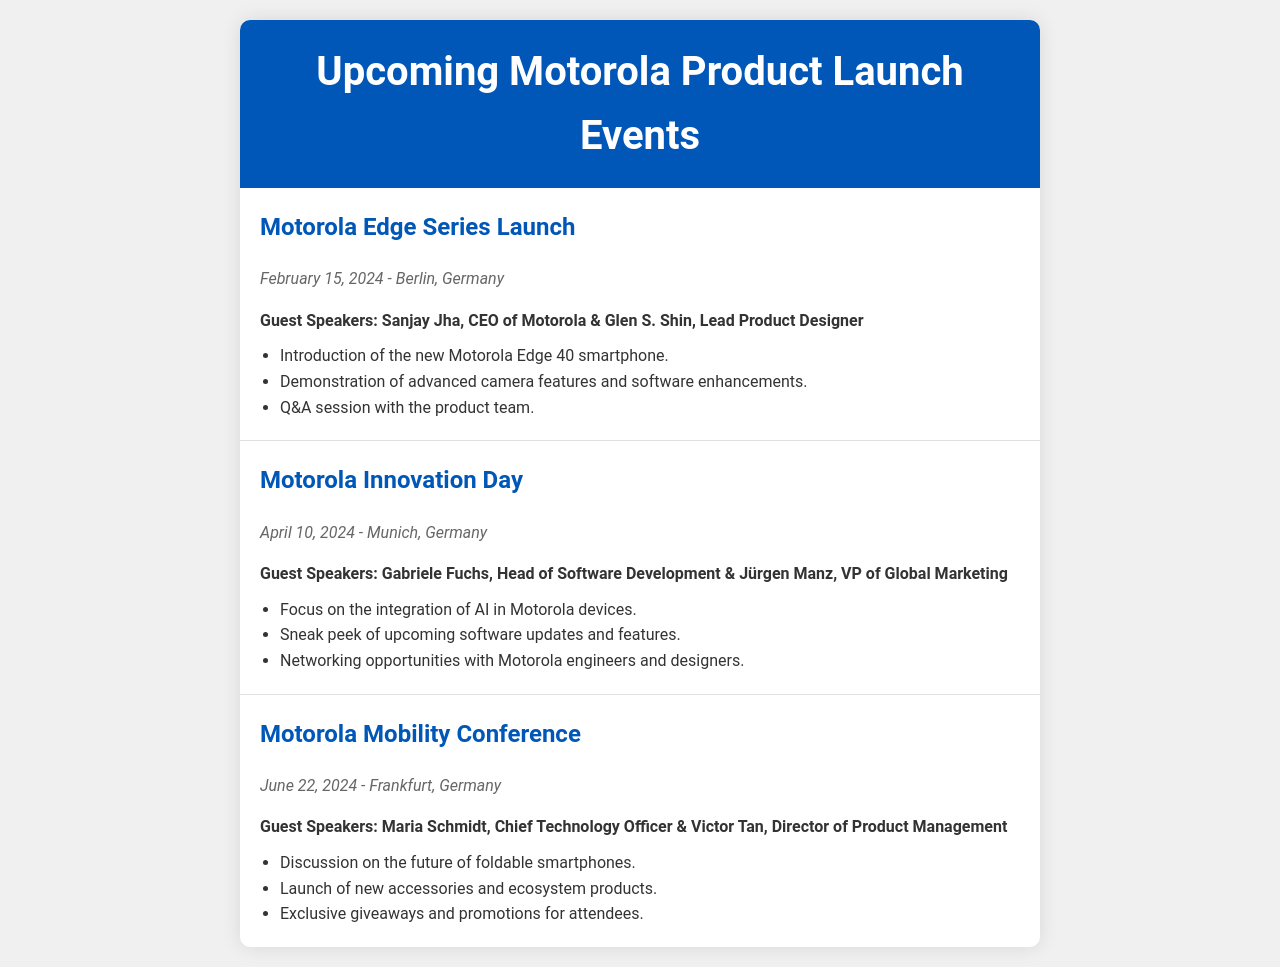What is the date of the Motorola Edge Series Launch? The document states that the Motorola Edge Series Launch is scheduled for February 15, 2024.
Answer: February 15, 2024 Who are the guest speakers at the Motorola Innovation Day? The document lists Gabriele Fuchs and Jürgen Manz as the guest speakers for the Motorola Innovation Day.
Answer: Gabriele Fuchs, Jürgen Manz Which city will host the Motorola Mobility Conference? According to the document, the Motorola Mobility Conference will take place in Frankfurt, Germany.
Answer: Frankfurt, Germany How many events are listed in the document? The document includes a total of three events.
Answer: Three What is a key focus of the Motorola Innovation Day? The document highlights that the focus of the Motorola Innovation Day is the integration of AI in Motorola devices.
Answer: Integration of AI in Motorola devices Who is the CEO of Motorola? The document mentions Sanjay Jha as the CEO of Motorola.
Answer: Sanjay Jha What special activity will take place during the Motorola Edge Series Launch? The document indicates that there will be a Q&A session with the product team during the Motorola Edge Series Launch.
Answer: Q&A session When is the next event after the Motorola Edge Series Launch? The document states that the next event after the Motorola Edge Series Launch is the Motorola Innovation Day on April 10, 2024.
Answer: April 10, 2024 What type of opportunities are mentioned for attendees of the Motorola Innovation Day? The document states that there will be networking opportunities with Motorola engineers and designers.
Answer: Networking opportunities 